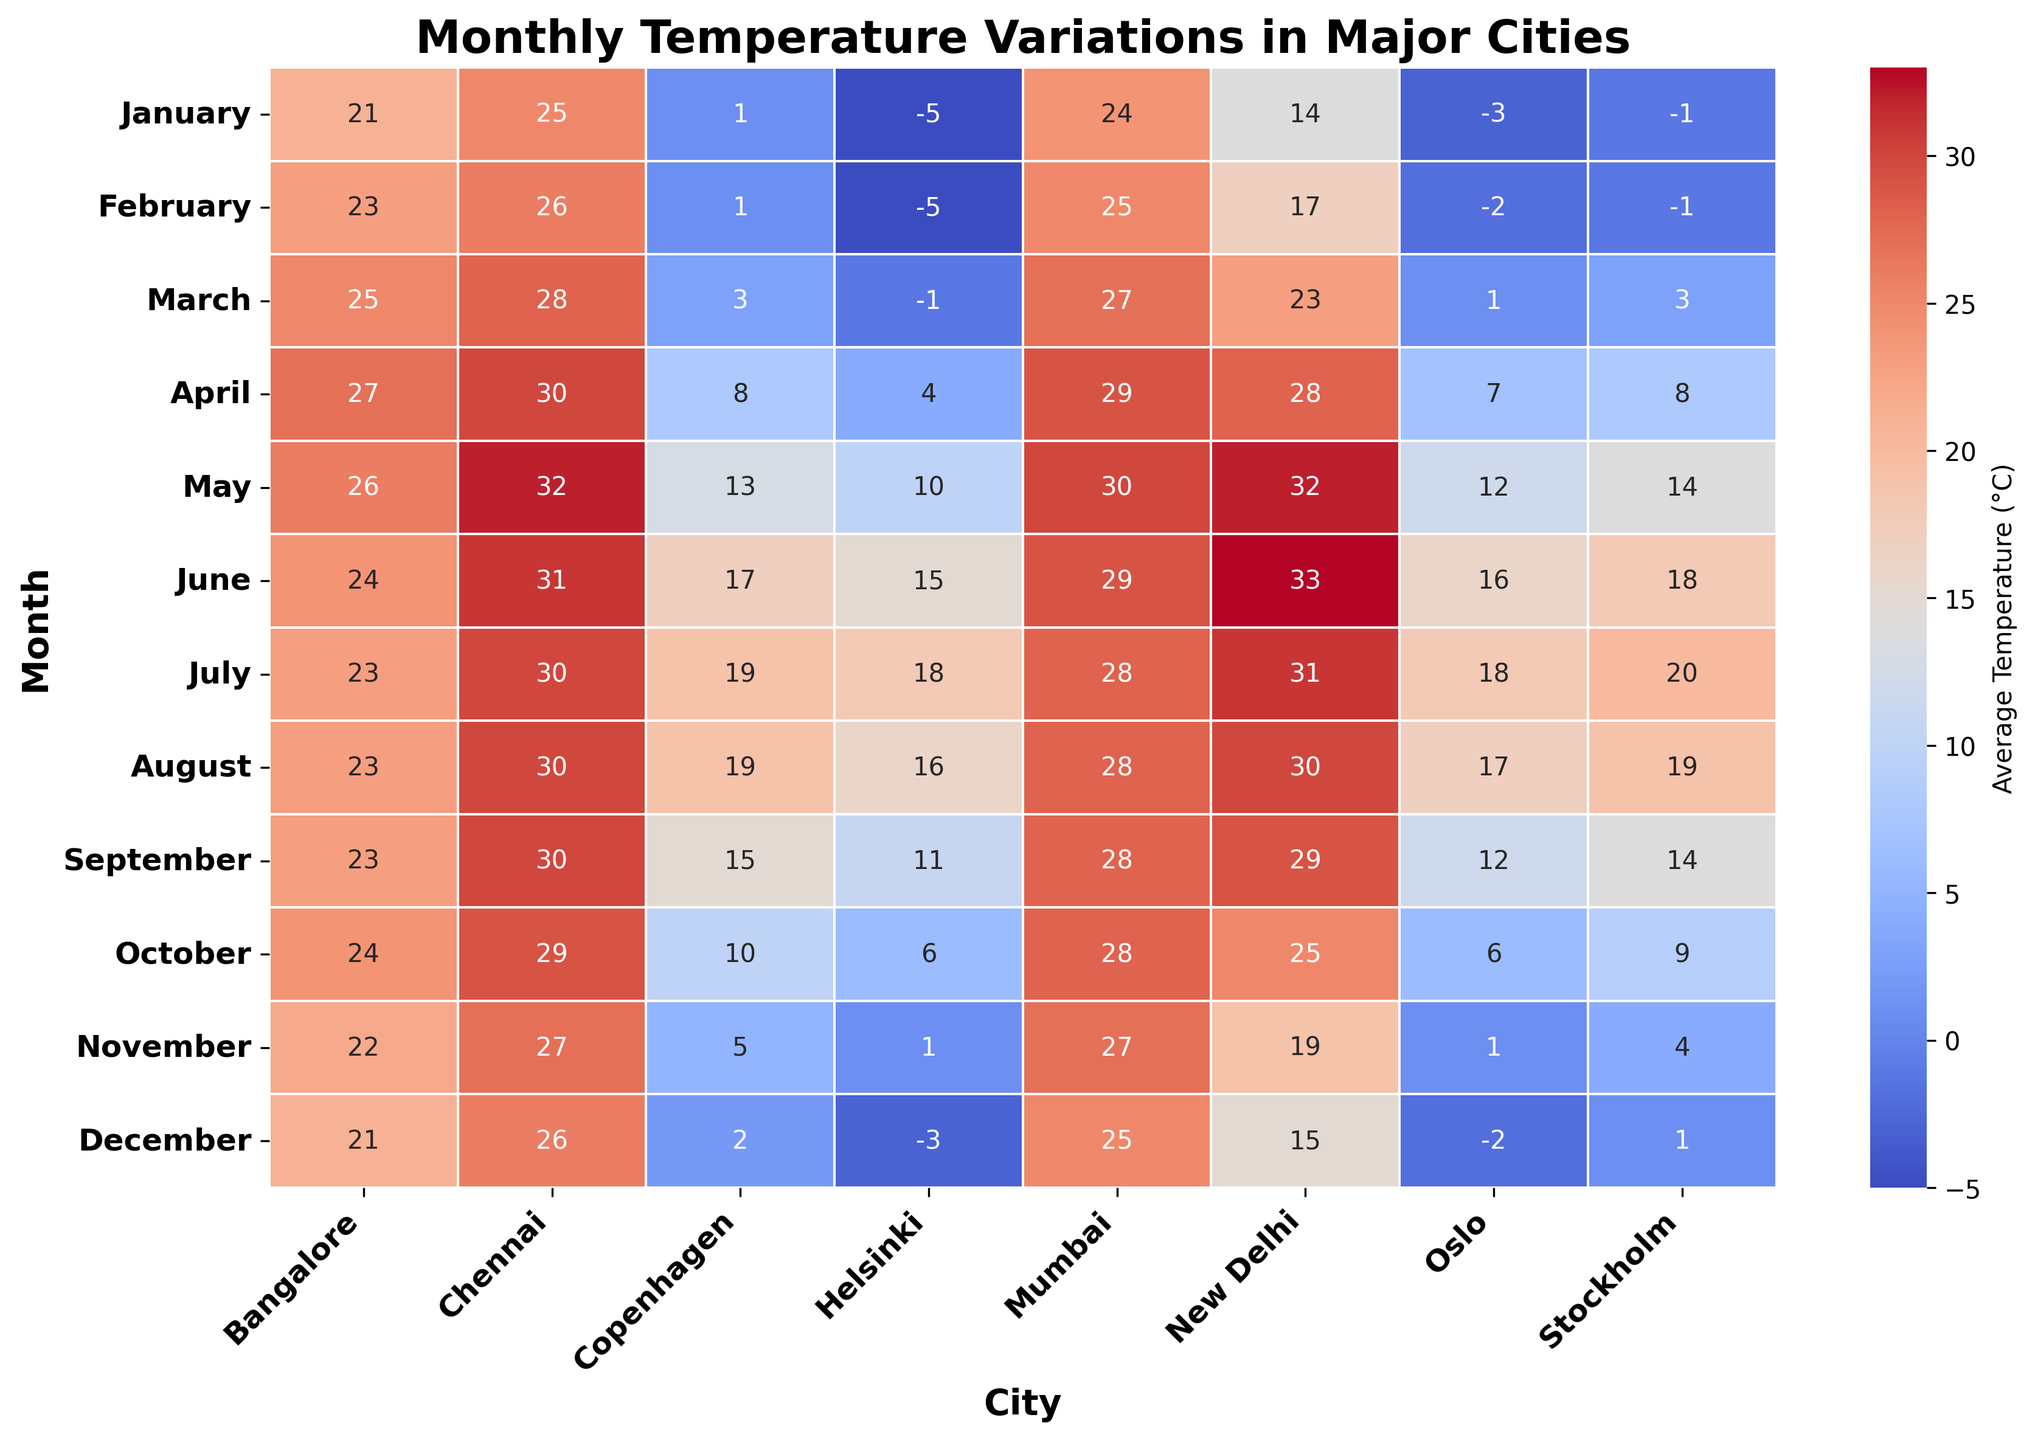What is the average temperature in Stockholm during the winter months (January, February, and December)? The average temperature is calculated by summing the temperatures of these months and dividing by 3: (-1) + (-1) + 1 = -1, and -1 / 3 = -0.33 (rounded to two decimal places).
Answer: -0.33°C Which city has the highest average temperature in January? From the heatmap's January row, look for the highest value. Chennai has 25°C, the highest among all cities listed.
Answer: Chennai How does the average temperature in Helsinki in March compare to March temperatures in Mumbai and New Delhi? Helsinki has an average of -1°C in March, whereas Mumbai has 27°C and New Delhi has 23°C. Thus, Helsinki is significantly colder than both Mumbai and New Delhi in March.
Answer: Helsinki is much colder Which city shows the smallest temperature variation throughout the year? Observe the colors in the heatmap for each city; Mumbai shows the least variation as the colors (temperatures) change very little from month to month, staying around 24-30°C.
Answer: Mumbai During which month is the temperature difference between Bangalore and Stockholm the greatest, and what is the difference? Look for the month with the most significant color difference between Bangalore and Stockholm: In June, Bangalore has 24°C, and Stockholm has 18°C, so the difference is 6°C.
Answer: June, 6°C In which months does New Delhi experience average temperatures above 30°C? Refer to the highlighted temperatures for New Delhi, noting months above 30°C: May (32°C), June (33°C), July (31°C), and August (30°C).
Answer: May, June, July, August Does Copenhagen or Oslo experience more months with temperatures below 5°C? Counting the months below 5°C for each: Copenhagen (January, February, March, November, December, totaling 5 months); Oslo (January, February, March, November, December, totaling 5 months). Both have the same number of months below 5°C.
Answer: Both have 5 months Which city has the warmest average temperature in July and what is that temperature? From the heatmap, the warmest city in July is New Delhi with an average temperature of 31°C.
Answer: New Delhi, 31°C Comparing Chennai and Bangalore, which city has a more stable average temperature across all months, and how can you tell? Bangalore has more consistent colors ranging from approximately 21°C to 27°C. Chennai varies from about 25°C to 32°C. Thus, Bangalore is more stable.
Answer: Bangalore What’s the average temperature range (difference between the highest and lowest average temperatures) in Helsinki? Helsinki's warmest month is July (18°C), and coldest is January and February (-5°C). The range is 18 - (-5) = 23°C.
Answer: 23°C 